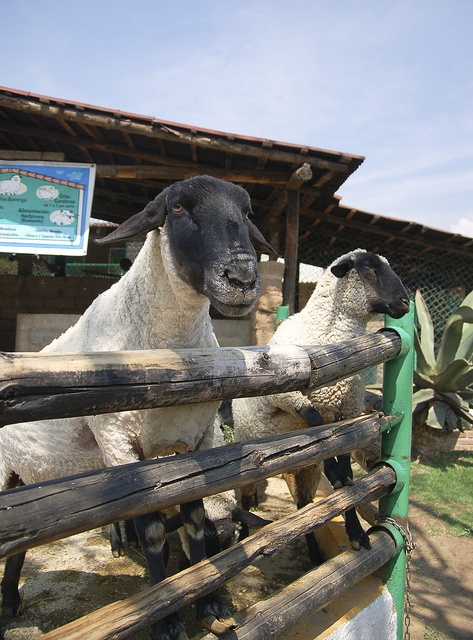Describe the objects in this image and their specific colors. I can see sheep in darkgray, gray, black, and lightgray tones, sheep in darkgray, black, ivory, and gray tones, and potted plant in darkgray, black, gray, darkgreen, and beige tones in this image. 